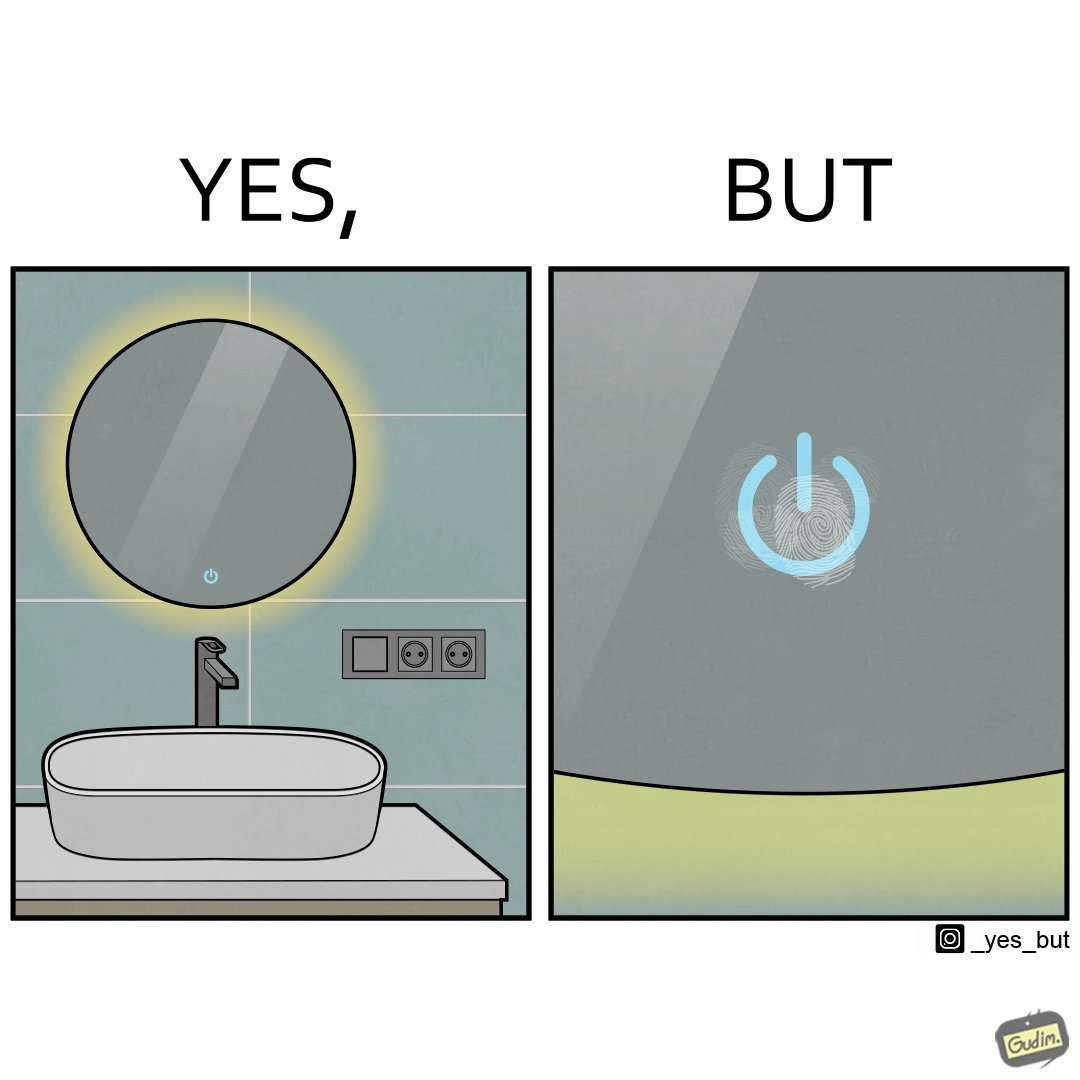Is there satirical content in this image? Yes, this image is satirical. 